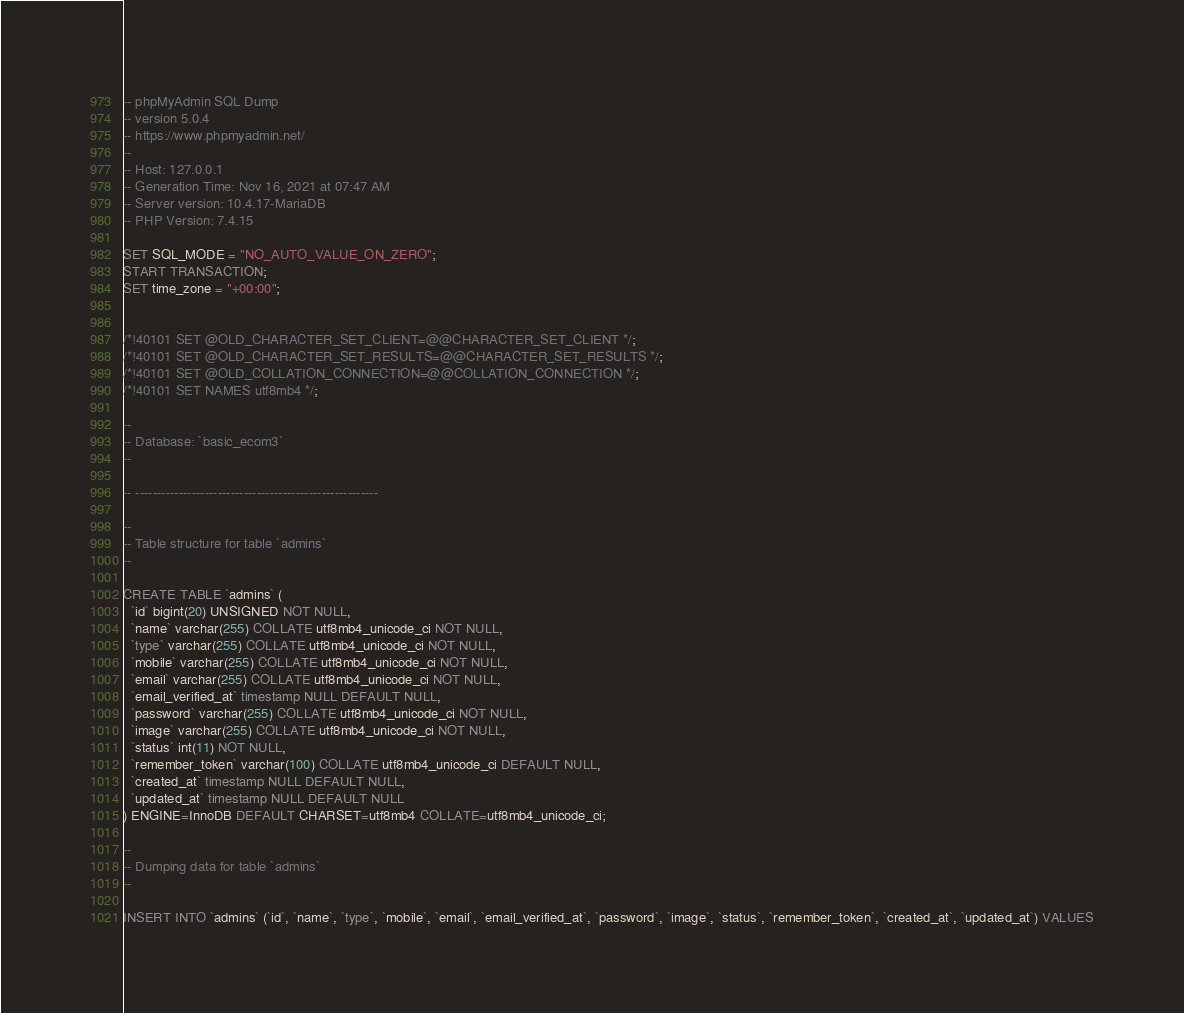<code> <loc_0><loc_0><loc_500><loc_500><_SQL_>-- phpMyAdmin SQL Dump
-- version 5.0.4
-- https://www.phpmyadmin.net/
--
-- Host: 127.0.0.1
-- Generation Time: Nov 16, 2021 at 07:47 AM
-- Server version: 10.4.17-MariaDB
-- PHP Version: 7.4.15

SET SQL_MODE = "NO_AUTO_VALUE_ON_ZERO";
START TRANSACTION;
SET time_zone = "+00:00";


/*!40101 SET @OLD_CHARACTER_SET_CLIENT=@@CHARACTER_SET_CLIENT */;
/*!40101 SET @OLD_CHARACTER_SET_RESULTS=@@CHARACTER_SET_RESULTS */;
/*!40101 SET @OLD_COLLATION_CONNECTION=@@COLLATION_CONNECTION */;
/*!40101 SET NAMES utf8mb4 */;

--
-- Database: `basic_ecom3`
--

-- --------------------------------------------------------

--
-- Table structure for table `admins`
--

CREATE TABLE `admins` (
  `id` bigint(20) UNSIGNED NOT NULL,
  `name` varchar(255) COLLATE utf8mb4_unicode_ci NOT NULL,
  `type` varchar(255) COLLATE utf8mb4_unicode_ci NOT NULL,
  `mobile` varchar(255) COLLATE utf8mb4_unicode_ci NOT NULL,
  `email` varchar(255) COLLATE utf8mb4_unicode_ci NOT NULL,
  `email_verified_at` timestamp NULL DEFAULT NULL,
  `password` varchar(255) COLLATE utf8mb4_unicode_ci NOT NULL,
  `image` varchar(255) COLLATE utf8mb4_unicode_ci NOT NULL,
  `status` int(11) NOT NULL,
  `remember_token` varchar(100) COLLATE utf8mb4_unicode_ci DEFAULT NULL,
  `created_at` timestamp NULL DEFAULT NULL,
  `updated_at` timestamp NULL DEFAULT NULL
) ENGINE=InnoDB DEFAULT CHARSET=utf8mb4 COLLATE=utf8mb4_unicode_ci;

--
-- Dumping data for table `admins`
--

INSERT INTO `admins` (`id`, `name`, `type`, `mobile`, `email`, `email_verified_at`, `password`, `image`, `status`, `remember_token`, `created_at`, `updated_at`) VALUES</code> 